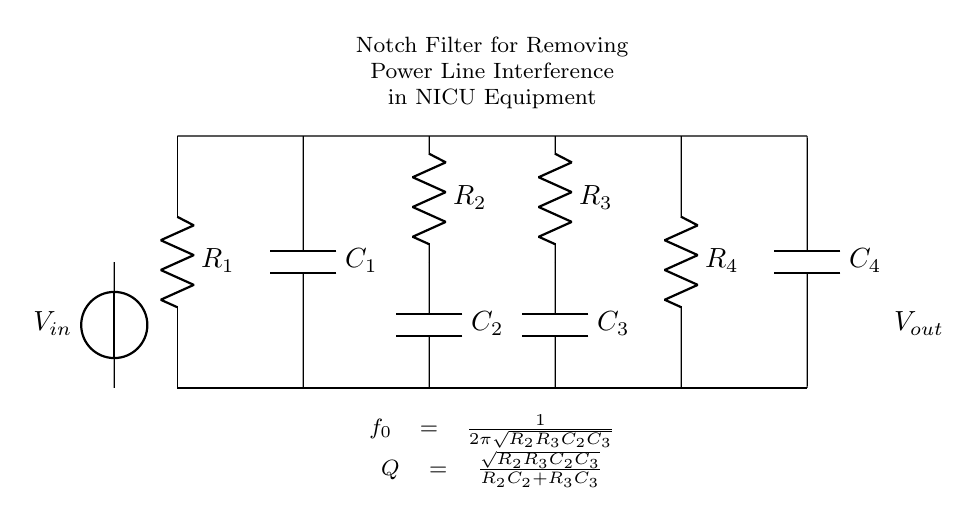What is the main purpose of this circuit? The circuit is a notch filter designed specifically to remove power line interference from equipment used in a neonatal intensive care unit. This is aimed at ensuring that sensitive measurements and signals from medical equipment are not affected by electrical noise.
Answer: notch filter How many resistors are in this circuit? The circuit has four resistors labeled R1, R2, R3, and R4. Each resistor plays a role in shaping the frequency response of the notch filter.
Answer: four What is the significance of the frequency \( f_0 \) in this circuit? The frequency \( f_0 \) is crucial as it denotes the center frequency at which the notch filter is designed to attenuate signals. The formula provided helps calculate \( f_0 \) based on the resistor and capacitor values, underscoring its significance in targeting power line noise.
Answer: center frequency What components create the notch filtering effect? The combination of the resistors R2 and R3 with capacitors C2 and C3 is responsible for establishing the notch filtering effect by forming a parallel resonant circuit that specifically attenuates the frequency \( f_0 \).
Answer: R2, R3, C2, C3 What does the symbol \( V_{in} \) represent in the circuit? \( V_{in} \) represents the input voltage source, indicating where the signal enters the circuit for filtering. Understanding this helps in analyzing how the original signal is processed through the notch filter.
Answer: input voltage What does the equation for \( Q \) represent in this circuit? The equation for \( Q \) describes the quality factor of the notch filter, which indicates how selective the filter is at rejecting frequencies. A higher \( Q \) factor implies a sharper notch, while a lower \( Q \) leads to a broader response. The equation uses the resistance and capacitance values in the circuit to quantify this selectivity.
Answer: quality factor 